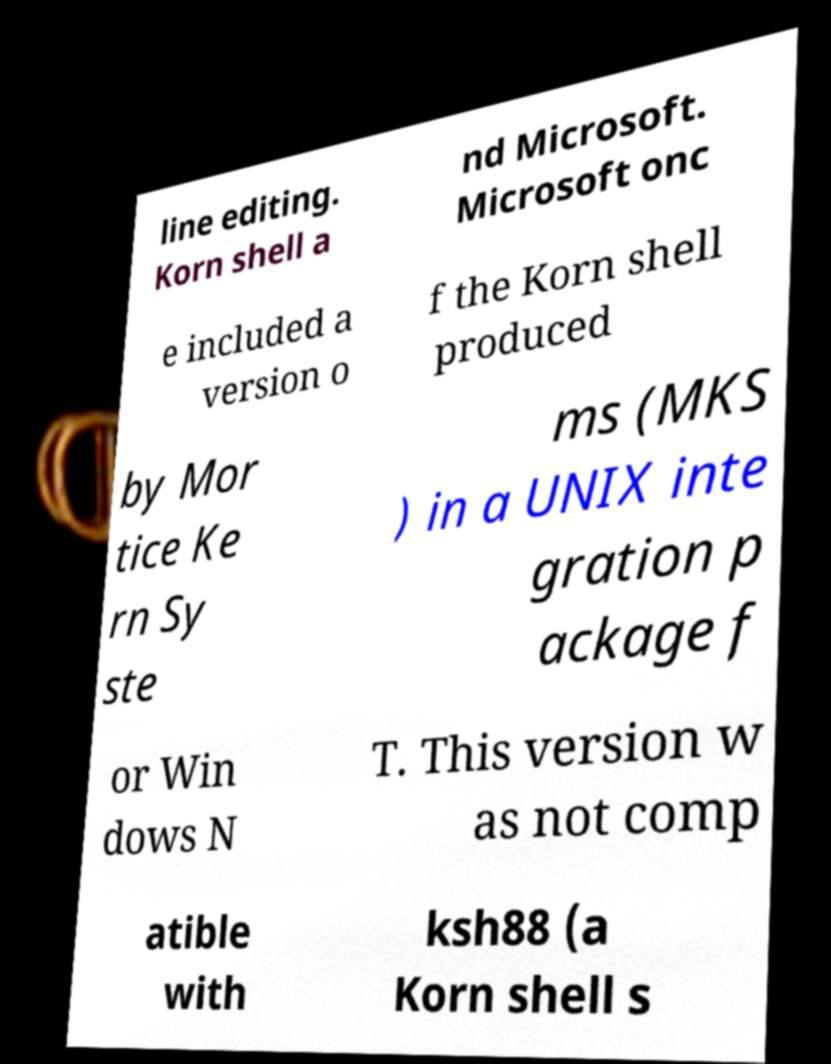What messages or text are displayed in this image? I need them in a readable, typed format. line editing. Korn shell a nd Microsoft. Microsoft onc e included a version o f the Korn shell produced by Mor tice Ke rn Sy ste ms (MKS ) in a UNIX inte gration p ackage f or Win dows N T. This version w as not comp atible with ksh88 (a Korn shell s 